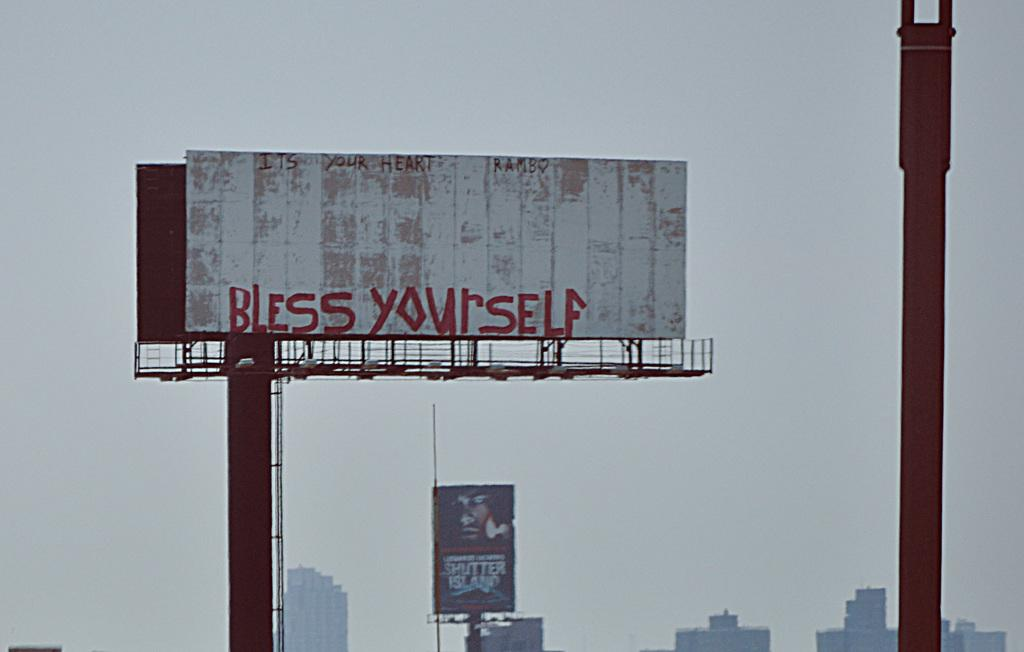Provide a one-sentence caption for the provided image. Bless yourself banner on top of a long pole. 